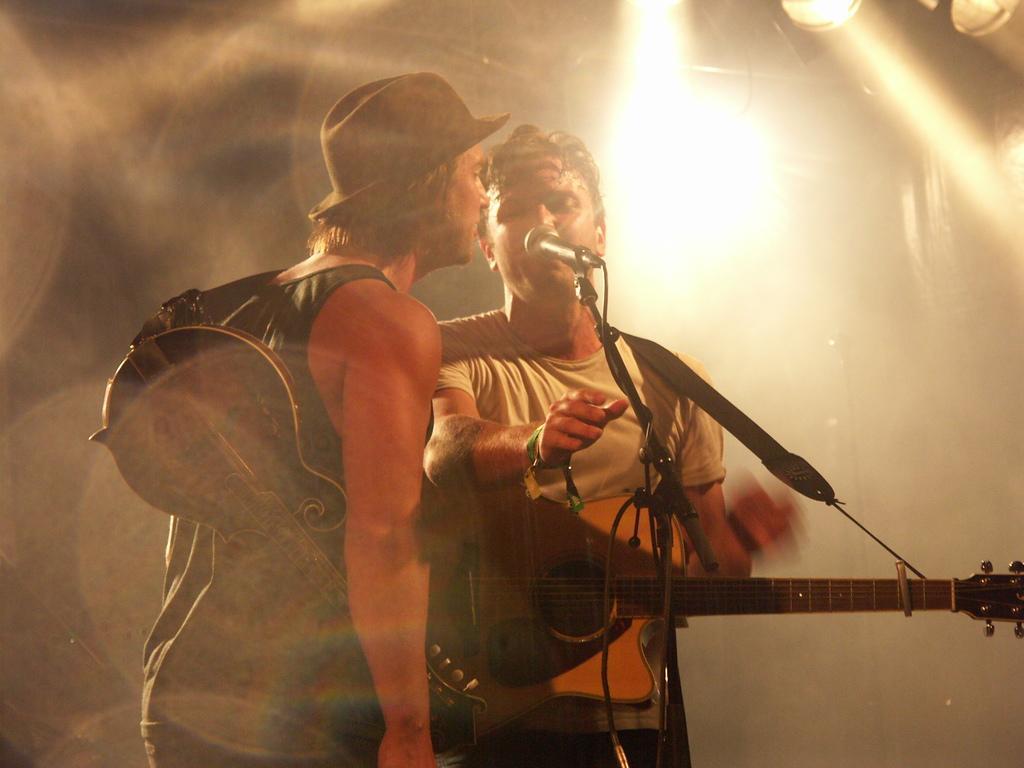Can you describe this image briefly? This pic this picture shows two men standing and holding guitar in their hand and they are singing with the help of a microphone in front of them 